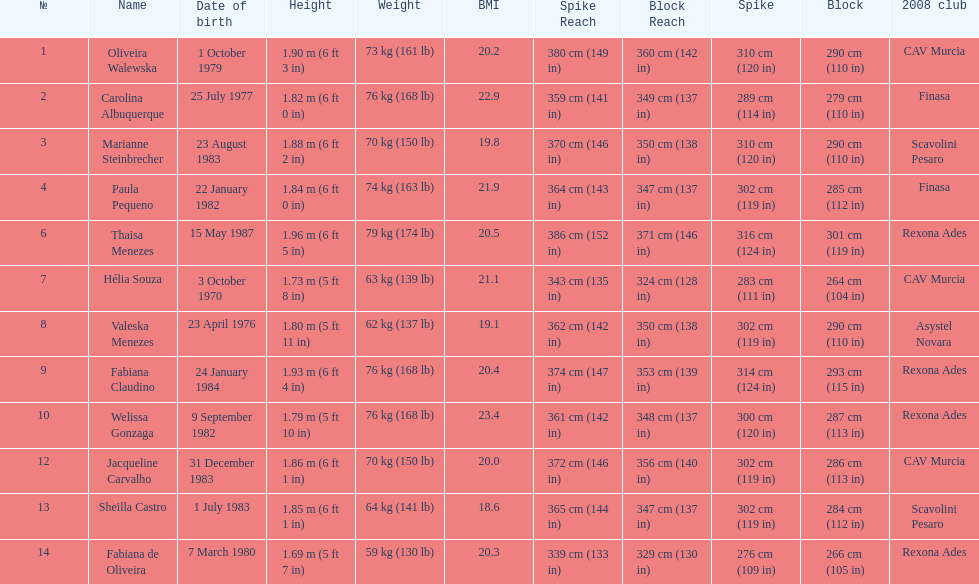Oliveira walewska has the same block as how many other players? 2. 